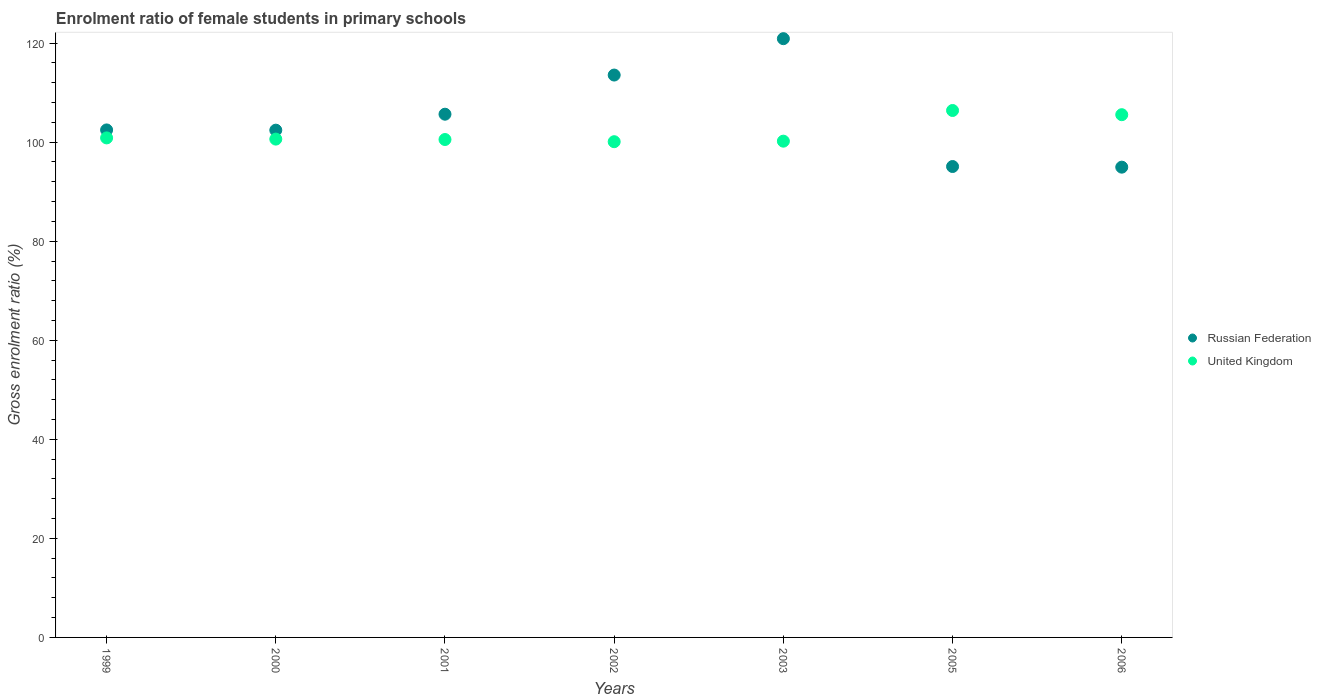Is the number of dotlines equal to the number of legend labels?
Make the answer very short. Yes. What is the enrolment ratio of female students in primary schools in Russian Federation in 2006?
Make the answer very short. 94.96. Across all years, what is the maximum enrolment ratio of female students in primary schools in United Kingdom?
Keep it short and to the point. 106.4. Across all years, what is the minimum enrolment ratio of female students in primary schools in United Kingdom?
Your response must be concise. 100.1. What is the total enrolment ratio of female students in primary schools in United Kingdom in the graph?
Offer a very short reply. 714.29. What is the difference between the enrolment ratio of female students in primary schools in United Kingdom in 2003 and that in 2005?
Provide a succinct answer. -6.19. What is the difference between the enrolment ratio of female students in primary schools in United Kingdom in 2002 and the enrolment ratio of female students in primary schools in Russian Federation in 2001?
Offer a terse response. -5.55. What is the average enrolment ratio of female students in primary schools in United Kingdom per year?
Make the answer very short. 102.04. In the year 2002, what is the difference between the enrolment ratio of female students in primary schools in Russian Federation and enrolment ratio of female students in primary schools in United Kingdom?
Provide a succinct answer. 13.46. What is the ratio of the enrolment ratio of female students in primary schools in Russian Federation in 2000 to that in 2006?
Provide a short and direct response. 1.08. What is the difference between the highest and the second highest enrolment ratio of female students in primary schools in Russian Federation?
Ensure brevity in your answer.  7.34. What is the difference between the highest and the lowest enrolment ratio of female students in primary schools in United Kingdom?
Ensure brevity in your answer.  6.3. Is the sum of the enrolment ratio of female students in primary schools in Russian Federation in 1999 and 2005 greater than the maximum enrolment ratio of female students in primary schools in United Kingdom across all years?
Keep it short and to the point. Yes. Is the enrolment ratio of female students in primary schools in United Kingdom strictly greater than the enrolment ratio of female students in primary schools in Russian Federation over the years?
Offer a terse response. No. How many years are there in the graph?
Provide a succinct answer. 7. What is the difference between two consecutive major ticks on the Y-axis?
Offer a terse response. 20. Are the values on the major ticks of Y-axis written in scientific E-notation?
Offer a terse response. No. Does the graph contain any zero values?
Your answer should be compact. No. How are the legend labels stacked?
Offer a terse response. Vertical. What is the title of the graph?
Make the answer very short. Enrolment ratio of female students in primary schools. Does "Angola" appear as one of the legend labels in the graph?
Give a very brief answer. No. What is the label or title of the X-axis?
Keep it short and to the point. Years. What is the Gross enrolment ratio (%) in Russian Federation in 1999?
Give a very brief answer. 102.47. What is the Gross enrolment ratio (%) of United Kingdom in 1999?
Provide a succinct answer. 100.87. What is the Gross enrolment ratio (%) in Russian Federation in 2000?
Ensure brevity in your answer.  102.43. What is the Gross enrolment ratio (%) of United Kingdom in 2000?
Keep it short and to the point. 100.62. What is the Gross enrolment ratio (%) of Russian Federation in 2001?
Offer a terse response. 105.65. What is the Gross enrolment ratio (%) of United Kingdom in 2001?
Keep it short and to the point. 100.54. What is the Gross enrolment ratio (%) of Russian Federation in 2002?
Provide a succinct answer. 113.56. What is the Gross enrolment ratio (%) of United Kingdom in 2002?
Your answer should be very brief. 100.1. What is the Gross enrolment ratio (%) in Russian Federation in 2003?
Your response must be concise. 120.9. What is the Gross enrolment ratio (%) of United Kingdom in 2003?
Give a very brief answer. 100.21. What is the Gross enrolment ratio (%) in Russian Federation in 2005?
Your answer should be compact. 95.09. What is the Gross enrolment ratio (%) in United Kingdom in 2005?
Make the answer very short. 106.4. What is the Gross enrolment ratio (%) of Russian Federation in 2006?
Your answer should be compact. 94.96. What is the Gross enrolment ratio (%) of United Kingdom in 2006?
Ensure brevity in your answer.  105.55. Across all years, what is the maximum Gross enrolment ratio (%) in Russian Federation?
Provide a short and direct response. 120.9. Across all years, what is the maximum Gross enrolment ratio (%) in United Kingdom?
Offer a terse response. 106.4. Across all years, what is the minimum Gross enrolment ratio (%) in Russian Federation?
Provide a short and direct response. 94.96. Across all years, what is the minimum Gross enrolment ratio (%) of United Kingdom?
Your answer should be compact. 100.1. What is the total Gross enrolment ratio (%) of Russian Federation in the graph?
Provide a short and direct response. 735.06. What is the total Gross enrolment ratio (%) of United Kingdom in the graph?
Make the answer very short. 714.29. What is the difference between the Gross enrolment ratio (%) of Russian Federation in 1999 and that in 2000?
Your response must be concise. 0.05. What is the difference between the Gross enrolment ratio (%) in United Kingdom in 1999 and that in 2000?
Your answer should be compact. 0.24. What is the difference between the Gross enrolment ratio (%) of Russian Federation in 1999 and that in 2001?
Your response must be concise. -3.18. What is the difference between the Gross enrolment ratio (%) of United Kingdom in 1999 and that in 2001?
Offer a very short reply. 0.33. What is the difference between the Gross enrolment ratio (%) in Russian Federation in 1999 and that in 2002?
Your answer should be very brief. -11.08. What is the difference between the Gross enrolment ratio (%) of United Kingdom in 1999 and that in 2002?
Ensure brevity in your answer.  0.77. What is the difference between the Gross enrolment ratio (%) of Russian Federation in 1999 and that in 2003?
Your answer should be very brief. -18.43. What is the difference between the Gross enrolment ratio (%) in United Kingdom in 1999 and that in 2003?
Provide a succinct answer. 0.66. What is the difference between the Gross enrolment ratio (%) of Russian Federation in 1999 and that in 2005?
Offer a very short reply. 7.39. What is the difference between the Gross enrolment ratio (%) of United Kingdom in 1999 and that in 2005?
Offer a terse response. -5.53. What is the difference between the Gross enrolment ratio (%) of Russian Federation in 1999 and that in 2006?
Provide a succinct answer. 7.52. What is the difference between the Gross enrolment ratio (%) in United Kingdom in 1999 and that in 2006?
Your answer should be compact. -4.69. What is the difference between the Gross enrolment ratio (%) of Russian Federation in 2000 and that in 2001?
Keep it short and to the point. -3.22. What is the difference between the Gross enrolment ratio (%) of United Kingdom in 2000 and that in 2001?
Provide a short and direct response. 0.08. What is the difference between the Gross enrolment ratio (%) in Russian Federation in 2000 and that in 2002?
Provide a short and direct response. -11.13. What is the difference between the Gross enrolment ratio (%) of United Kingdom in 2000 and that in 2002?
Keep it short and to the point. 0.52. What is the difference between the Gross enrolment ratio (%) of Russian Federation in 2000 and that in 2003?
Give a very brief answer. -18.48. What is the difference between the Gross enrolment ratio (%) in United Kingdom in 2000 and that in 2003?
Provide a short and direct response. 0.42. What is the difference between the Gross enrolment ratio (%) in Russian Federation in 2000 and that in 2005?
Make the answer very short. 7.34. What is the difference between the Gross enrolment ratio (%) of United Kingdom in 2000 and that in 2005?
Offer a very short reply. -5.78. What is the difference between the Gross enrolment ratio (%) of Russian Federation in 2000 and that in 2006?
Keep it short and to the point. 7.47. What is the difference between the Gross enrolment ratio (%) in United Kingdom in 2000 and that in 2006?
Your answer should be very brief. -4.93. What is the difference between the Gross enrolment ratio (%) in Russian Federation in 2001 and that in 2002?
Give a very brief answer. -7.91. What is the difference between the Gross enrolment ratio (%) of United Kingdom in 2001 and that in 2002?
Ensure brevity in your answer.  0.44. What is the difference between the Gross enrolment ratio (%) in Russian Federation in 2001 and that in 2003?
Make the answer very short. -15.25. What is the difference between the Gross enrolment ratio (%) in United Kingdom in 2001 and that in 2003?
Keep it short and to the point. 0.33. What is the difference between the Gross enrolment ratio (%) in Russian Federation in 2001 and that in 2005?
Keep it short and to the point. 10.56. What is the difference between the Gross enrolment ratio (%) of United Kingdom in 2001 and that in 2005?
Offer a terse response. -5.86. What is the difference between the Gross enrolment ratio (%) in Russian Federation in 2001 and that in 2006?
Give a very brief answer. 10.69. What is the difference between the Gross enrolment ratio (%) of United Kingdom in 2001 and that in 2006?
Ensure brevity in your answer.  -5.01. What is the difference between the Gross enrolment ratio (%) of Russian Federation in 2002 and that in 2003?
Offer a terse response. -7.34. What is the difference between the Gross enrolment ratio (%) of United Kingdom in 2002 and that in 2003?
Your response must be concise. -0.11. What is the difference between the Gross enrolment ratio (%) of Russian Federation in 2002 and that in 2005?
Keep it short and to the point. 18.47. What is the difference between the Gross enrolment ratio (%) in United Kingdom in 2002 and that in 2005?
Your answer should be very brief. -6.3. What is the difference between the Gross enrolment ratio (%) of Russian Federation in 2002 and that in 2006?
Offer a terse response. 18.6. What is the difference between the Gross enrolment ratio (%) in United Kingdom in 2002 and that in 2006?
Your response must be concise. -5.45. What is the difference between the Gross enrolment ratio (%) of Russian Federation in 2003 and that in 2005?
Provide a short and direct response. 25.81. What is the difference between the Gross enrolment ratio (%) in United Kingdom in 2003 and that in 2005?
Provide a succinct answer. -6.19. What is the difference between the Gross enrolment ratio (%) in Russian Federation in 2003 and that in 2006?
Make the answer very short. 25.94. What is the difference between the Gross enrolment ratio (%) in United Kingdom in 2003 and that in 2006?
Your answer should be very brief. -5.35. What is the difference between the Gross enrolment ratio (%) of Russian Federation in 2005 and that in 2006?
Provide a short and direct response. 0.13. What is the difference between the Gross enrolment ratio (%) of United Kingdom in 2005 and that in 2006?
Your answer should be very brief. 0.85. What is the difference between the Gross enrolment ratio (%) of Russian Federation in 1999 and the Gross enrolment ratio (%) of United Kingdom in 2000?
Your answer should be very brief. 1.85. What is the difference between the Gross enrolment ratio (%) in Russian Federation in 1999 and the Gross enrolment ratio (%) in United Kingdom in 2001?
Offer a terse response. 1.93. What is the difference between the Gross enrolment ratio (%) of Russian Federation in 1999 and the Gross enrolment ratio (%) of United Kingdom in 2002?
Your answer should be compact. 2.38. What is the difference between the Gross enrolment ratio (%) of Russian Federation in 1999 and the Gross enrolment ratio (%) of United Kingdom in 2003?
Provide a short and direct response. 2.27. What is the difference between the Gross enrolment ratio (%) in Russian Federation in 1999 and the Gross enrolment ratio (%) in United Kingdom in 2005?
Make the answer very short. -3.93. What is the difference between the Gross enrolment ratio (%) in Russian Federation in 1999 and the Gross enrolment ratio (%) in United Kingdom in 2006?
Provide a succinct answer. -3.08. What is the difference between the Gross enrolment ratio (%) of Russian Federation in 2000 and the Gross enrolment ratio (%) of United Kingdom in 2001?
Provide a short and direct response. 1.89. What is the difference between the Gross enrolment ratio (%) in Russian Federation in 2000 and the Gross enrolment ratio (%) in United Kingdom in 2002?
Give a very brief answer. 2.33. What is the difference between the Gross enrolment ratio (%) in Russian Federation in 2000 and the Gross enrolment ratio (%) in United Kingdom in 2003?
Provide a short and direct response. 2.22. What is the difference between the Gross enrolment ratio (%) of Russian Federation in 2000 and the Gross enrolment ratio (%) of United Kingdom in 2005?
Your answer should be very brief. -3.97. What is the difference between the Gross enrolment ratio (%) in Russian Federation in 2000 and the Gross enrolment ratio (%) in United Kingdom in 2006?
Give a very brief answer. -3.13. What is the difference between the Gross enrolment ratio (%) in Russian Federation in 2001 and the Gross enrolment ratio (%) in United Kingdom in 2002?
Ensure brevity in your answer.  5.55. What is the difference between the Gross enrolment ratio (%) of Russian Federation in 2001 and the Gross enrolment ratio (%) of United Kingdom in 2003?
Provide a succinct answer. 5.44. What is the difference between the Gross enrolment ratio (%) in Russian Federation in 2001 and the Gross enrolment ratio (%) in United Kingdom in 2005?
Give a very brief answer. -0.75. What is the difference between the Gross enrolment ratio (%) of Russian Federation in 2001 and the Gross enrolment ratio (%) of United Kingdom in 2006?
Give a very brief answer. 0.1. What is the difference between the Gross enrolment ratio (%) of Russian Federation in 2002 and the Gross enrolment ratio (%) of United Kingdom in 2003?
Offer a terse response. 13.35. What is the difference between the Gross enrolment ratio (%) in Russian Federation in 2002 and the Gross enrolment ratio (%) in United Kingdom in 2005?
Provide a short and direct response. 7.16. What is the difference between the Gross enrolment ratio (%) in Russian Federation in 2002 and the Gross enrolment ratio (%) in United Kingdom in 2006?
Keep it short and to the point. 8. What is the difference between the Gross enrolment ratio (%) in Russian Federation in 2003 and the Gross enrolment ratio (%) in United Kingdom in 2005?
Your answer should be very brief. 14.5. What is the difference between the Gross enrolment ratio (%) in Russian Federation in 2003 and the Gross enrolment ratio (%) in United Kingdom in 2006?
Make the answer very short. 15.35. What is the difference between the Gross enrolment ratio (%) of Russian Federation in 2005 and the Gross enrolment ratio (%) of United Kingdom in 2006?
Your answer should be compact. -10.46. What is the average Gross enrolment ratio (%) in Russian Federation per year?
Your response must be concise. 105.01. What is the average Gross enrolment ratio (%) in United Kingdom per year?
Your response must be concise. 102.04. In the year 1999, what is the difference between the Gross enrolment ratio (%) of Russian Federation and Gross enrolment ratio (%) of United Kingdom?
Ensure brevity in your answer.  1.61. In the year 2000, what is the difference between the Gross enrolment ratio (%) of Russian Federation and Gross enrolment ratio (%) of United Kingdom?
Provide a succinct answer. 1.8. In the year 2001, what is the difference between the Gross enrolment ratio (%) of Russian Federation and Gross enrolment ratio (%) of United Kingdom?
Your answer should be very brief. 5.11. In the year 2002, what is the difference between the Gross enrolment ratio (%) of Russian Federation and Gross enrolment ratio (%) of United Kingdom?
Ensure brevity in your answer.  13.46. In the year 2003, what is the difference between the Gross enrolment ratio (%) in Russian Federation and Gross enrolment ratio (%) in United Kingdom?
Your answer should be very brief. 20.7. In the year 2005, what is the difference between the Gross enrolment ratio (%) in Russian Federation and Gross enrolment ratio (%) in United Kingdom?
Your answer should be very brief. -11.31. In the year 2006, what is the difference between the Gross enrolment ratio (%) of Russian Federation and Gross enrolment ratio (%) of United Kingdom?
Your response must be concise. -10.59. What is the ratio of the Gross enrolment ratio (%) in Russian Federation in 1999 to that in 2001?
Provide a short and direct response. 0.97. What is the ratio of the Gross enrolment ratio (%) of Russian Federation in 1999 to that in 2002?
Offer a terse response. 0.9. What is the ratio of the Gross enrolment ratio (%) of United Kingdom in 1999 to that in 2002?
Give a very brief answer. 1.01. What is the ratio of the Gross enrolment ratio (%) of Russian Federation in 1999 to that in 2003?
Give a very brief answer. 0.85. What is the ratio of the Gross enrolment ratio (%) of United Kingdom in 1999 to that in 2003?
Keep it short and to the point. 1.01. What is the ratio of the Gross enrolment ratio (%) in Russian Federation in 1999 to that in 2005?
Your answer should be very brief. 1.08. What is the ratio of the Gross enrolment ratio (%) of United Kingdom in 1999 to that in 2005?
Offer a very short reply. 0.95. What is the ratio of the Gross enrolment ratio (%) of Russian Federation in 1999 to that in 2006?
Keep it short and to the point. 1.08. What is the ratio of the Gross enrolment ratio (%) in United Kingdom in 1999 to that in 2006?
Your answer should be compact. 0.96. What is the ratio of the Gross enrolment ratio (%) of Russian Federation in 2000 to that in 2001?
Your response must be concise. 0.97. What is the ratio of the Gross enrolment ratio (%) in Russian Federation in 2000 to that in 2002?
Ensure brevity in your answer.  0.9. What is the ratio of the Gross enrolment ratio (%) of Russian Federation in 2000 to that in 2003?
Your answer should be compact. 0.85. What is the ratio of the Gross enrolment ratio (%) in Russian Federation in 2000 to that in 2005?
Ensure brevity in your answer.  1.08. What is the ratio of the Gross enrolment ratio (%) of United Kingdom in 2000 to that in 2005?
Provide a succinct answer. 0.95. What is the ratio of the Gross enrolment ratio (%) of Russian Federation in 2000 to that in 2006?
Keep it short and to the point. 1.08. What is the ratio of the Gross enrolment ratio (%) of United Kingdom in 2000 to that in 2006?
Your response must be concise. 0.95. What is the ratio of the Gross enrolment ratio (%) of Russian Federation in 2001 to that in 2002?
Offer a very short reply. 0.93. What is the ratio of the Gross enrolment ratio (%) in United Kingdom in 2001 to that in 2002?
Offer a very short reply. 1. What is the ratio of the Gross enrolment ratio (%) in Russian Federation in 2001 to that in 2003?
Provide a short and direct response. 0.87. What is the ratio of the Gross enrolment ratio (%) in United Kingdom in 2001 to that in 2003?
Offer a terse response. 1. What is the ratio of the Gross enrolment ratio (%) in United Kingdom in 2001 to that in 2005?
Make the answer very short. 0.94. What is the ratio of the Gross enrolment ratio (%) of Russian Federation in 2001 to that in 2006?
Ensure brevity in your answer.  1.11. What is the ratio of the Gross enrolment ratio (%) in United Kingdom in 2001 to that in 2006?
Provide a short and direct response. 0.95. What is the ratio of the Gross enrolment ratio (%) of Russian Federation in 2002 to that in 2003?
Provide a succinct answer. 0.94. What is the ratio of the Gross enrolment ratio (%) of Russian Federation in 2002 to that in 2005?
Provide a succinct answer. 1.19. What is the ratio of the Gross enrolment ratio (%) of United Kingdom in 2002 to that in 2005?
Your answer should be compact. 0.94. What is the ratio of the Gross enrolment ratio (%) of Russian Federation in 2002 to that in 2006?
Provide a short and direct response. 1.2. What is the ratio of the Gross enrolment ratio (%) in United Kingdom in 2002 to that in 2006?
Ensure brevity in your answer.  0.95. What is the ratio of the Gross enrolment ratio (%) in Russian Federation in 2003 to that in 2005?
Offer a terse response. 1.27. What is the ratio of the Gross enrolment ratio (%) in United Kingdom in 2003 to that in 2005?
Ensure brevity in your answer.  0.94. What is the ratio of the Gross enrolment ratio (%) in Russian Federation in 2003 to that in 2006?
Ensure brevity in your answer.  1.27. What is the ratio of the Gross enrolment ratio (%) in United Kingdom in 2003 to that in 2006?
Offer a terse response. 0.95. What is the ratio of the Gross enrolment ratio (%) of Russian Federation in 2005 to that in 2006?
Your response must be concise. 1. What is the ratio of the Gross enrolment ratio (%) in United Kingdom in 2005 to that in 2006?
Keep it short and to the point. 1.01. What is the difference between the highest and the second highest Gross enrolment ratio (%) in Russian Federation?
Your answer should be compact. 7.34. What is the difference between the highest and the second highest Gross enrolment ratio (%) in United Kingdom?
Offer a terse response. 0.85. What is the difference between the highest and the lowest Gross enrolment ratio (%) of Russian Federation?
Provide a succinct answer. 25.94. What is the difference between the highest and the lowest Gross enrolment ratio (%) in United Kingdom?
Make the answer very short. 6.3. 